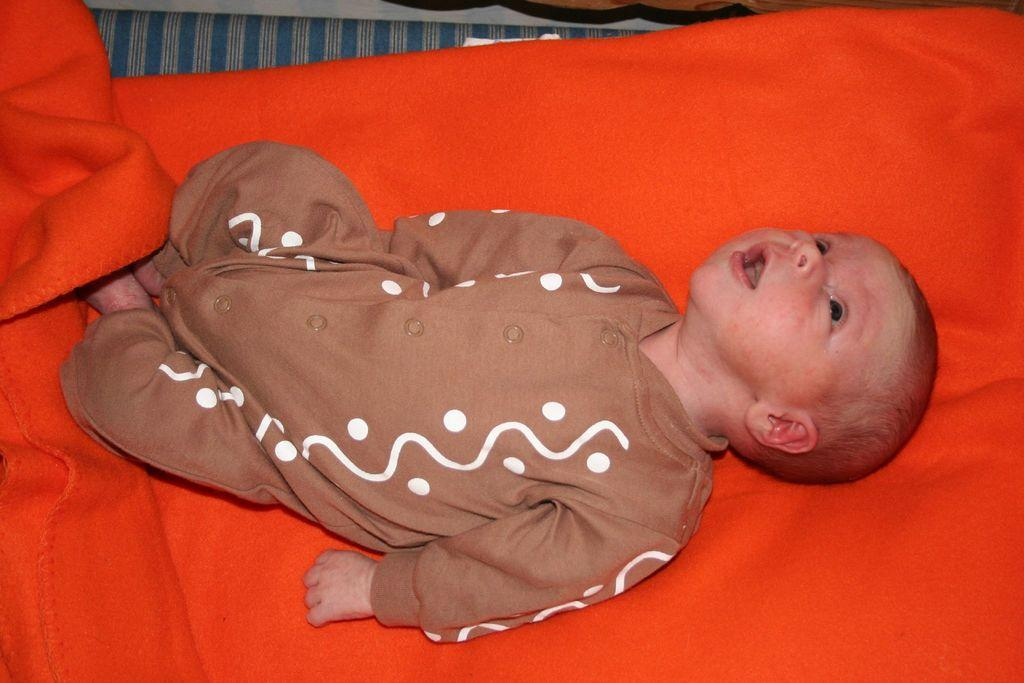What is the main subject of the image? There is a baby in the image. What is the baby lying on? The baby is lying on an orange cloth. Is the maid feeding the baby honey with her finger in the image? There is no maid, honey, or finger present in the image. 